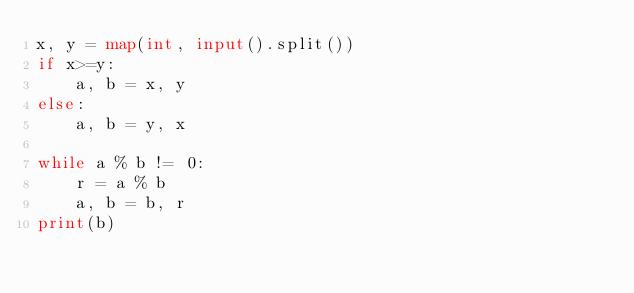Convert code to text. <code><loc_0><loc_0><loc_500><loc_500><_Python_>x, y = map(int, input().split())
if x>=y:
    a, b = x, y
else:
    a, b = y, x

while a % b != 0:
    r = a % b
    a, b = b, r
print(b)

</code> 